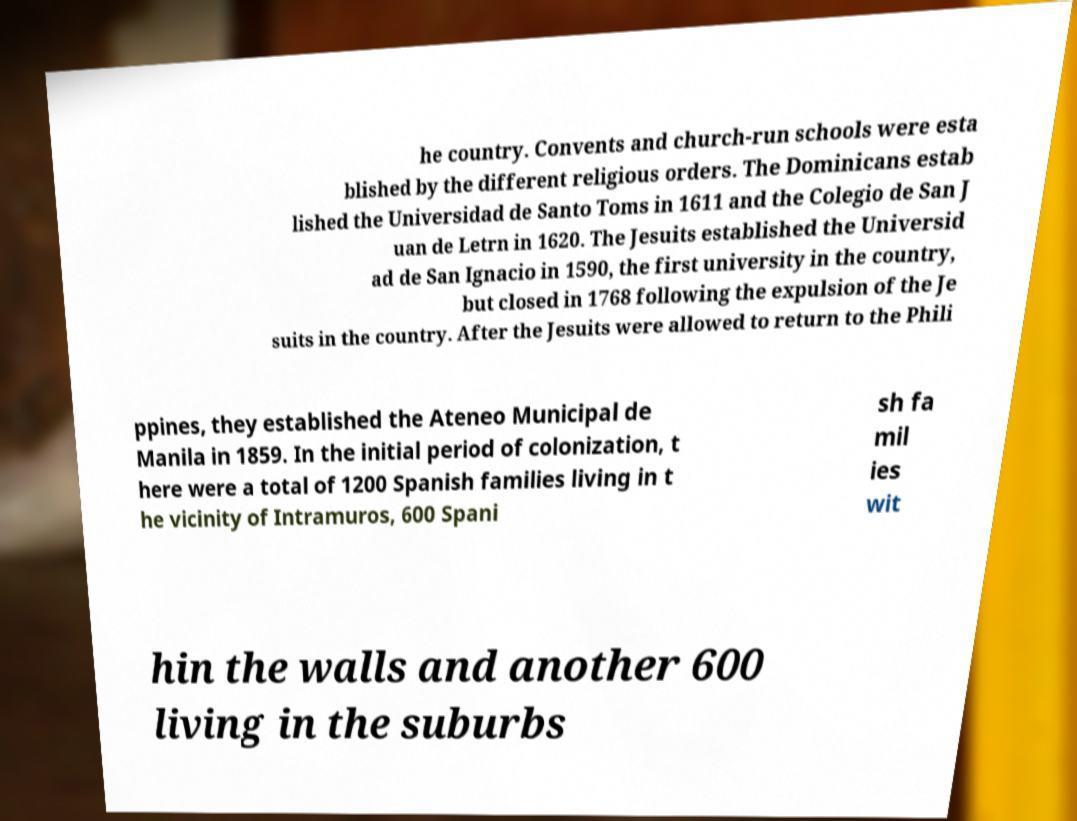What messages or text are displayed in this image? I need them in a readable, typed format. he country. Convents and church-run schools were esta blished by the different religious orders. The Dominicans estab lished the Universidad de Santo Toms in 1611 and the Colegio de San J uan de Letrn in 1620. The Jesuits established the Universid ad de San Ignacio in 1590, the first university in the country, but closed in 1768 following the expulsion of the Je suits in the country. After the Jesuits were allowed to return to the Phili ppines, they established the Ateneo Municipal de Manila in 1859. In the initial period of colonization, t here were a total of 1200 Spanish families living in t he vicinity of Intramuros, 600 Spani sh fa mil ies wit hin the walls and another 600 living in the suburbs 